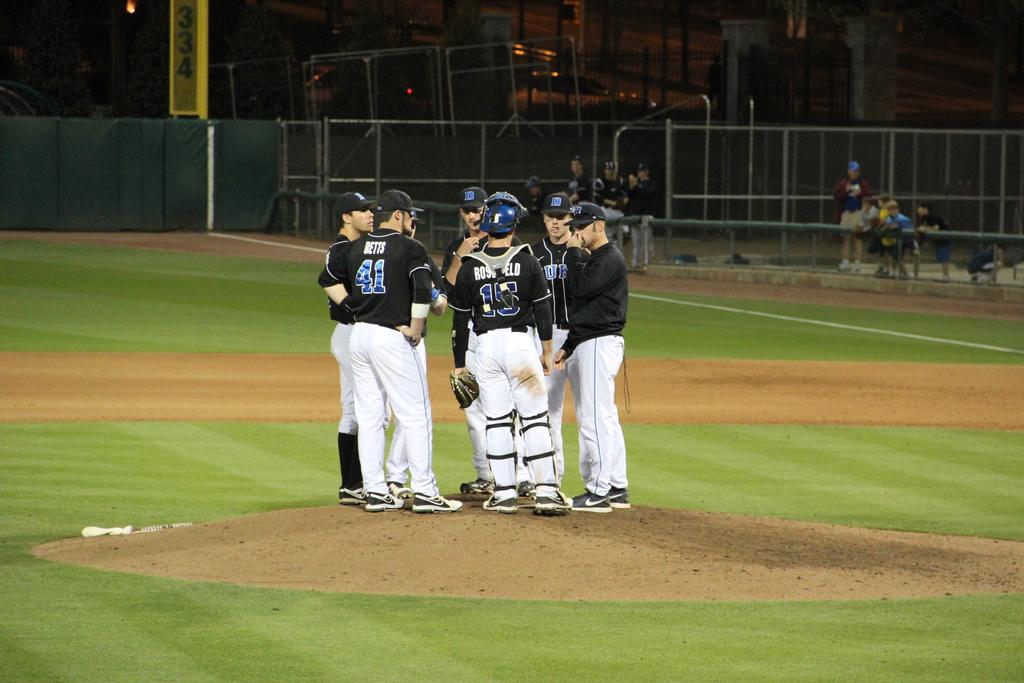What is the boy on the lefts jersey number?
Offer a terse response. 41. What is the catcher's number?
Offer a terse response. 15. 